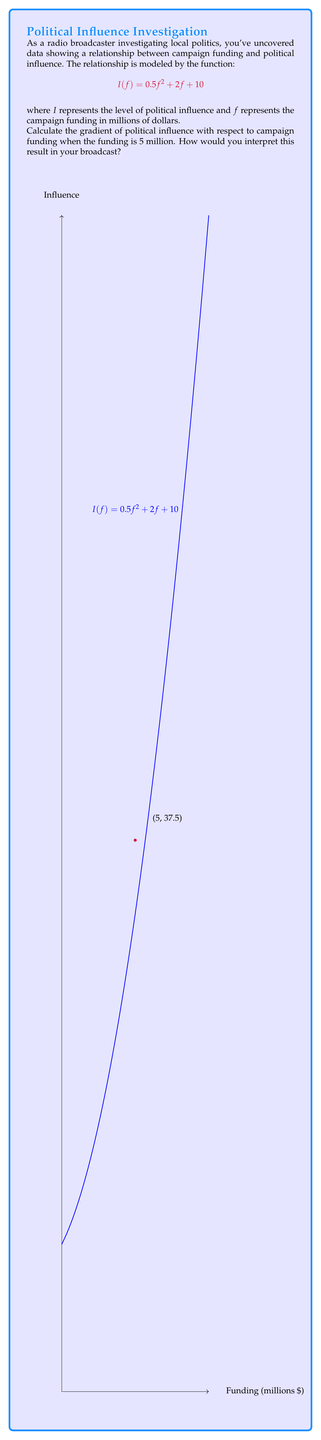What is the answer to this math problem? To solve this problem, we need to follow these steps:

1) The gradient is equivalent to the derivative of the function $I(f)$ with respect to $f$.

2) Let's find the derivative $\frac{dI}{df}$:
   $$\frac{dI}{df} = \frac{d}{df}(0.5f^2 + 2f + 10)$$
   $$\frac{dI}{df} = 0.5 \cdot 2f + 2 + 0$$
   $$\frac{dI}{df} = f + 2$$

3) Now, we need to evaluate this at $f = 5$:
   $$\frac{dI}{df}\bigg|_{f=5} = 5 + 2 = 7$$

4) Interpretation: The gradient of 7 means that when campaign funding is at $5 million, for each additional million dollars of funding, the political influence is increasing at a rate of 7 units.

5) In broadcasting terms, you could say: "Our investigation reveals that at the $5 million funding mark, each additional million dollars pumped into a campaign translates to a substantial boost of 7 points in our political influence scale. This accelerating trend suggests a concerning link between money and power in our local political landscape."
Answer: $\frac{dI}{df}\bigg|_{f=5} = 7$ 